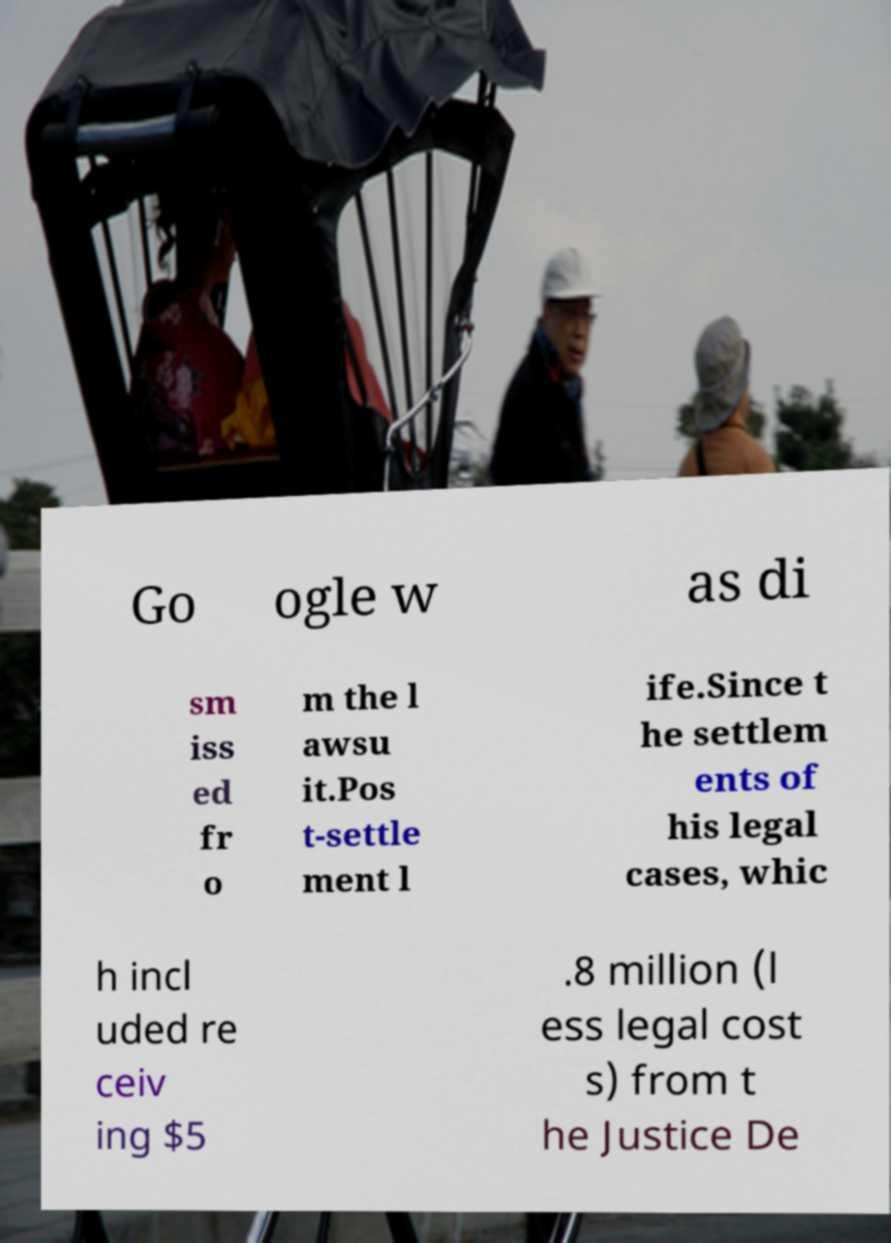Could you extract and type out the text from this image? Go ogle w as di sm iss ed fr o m the l awsu it.Pos t-settle ment l ife.Since t he settlem ents of his legal cases, whic h incl uded re ceiv ing $5 .8 million (l ess legal cost s) from t he Justice De 